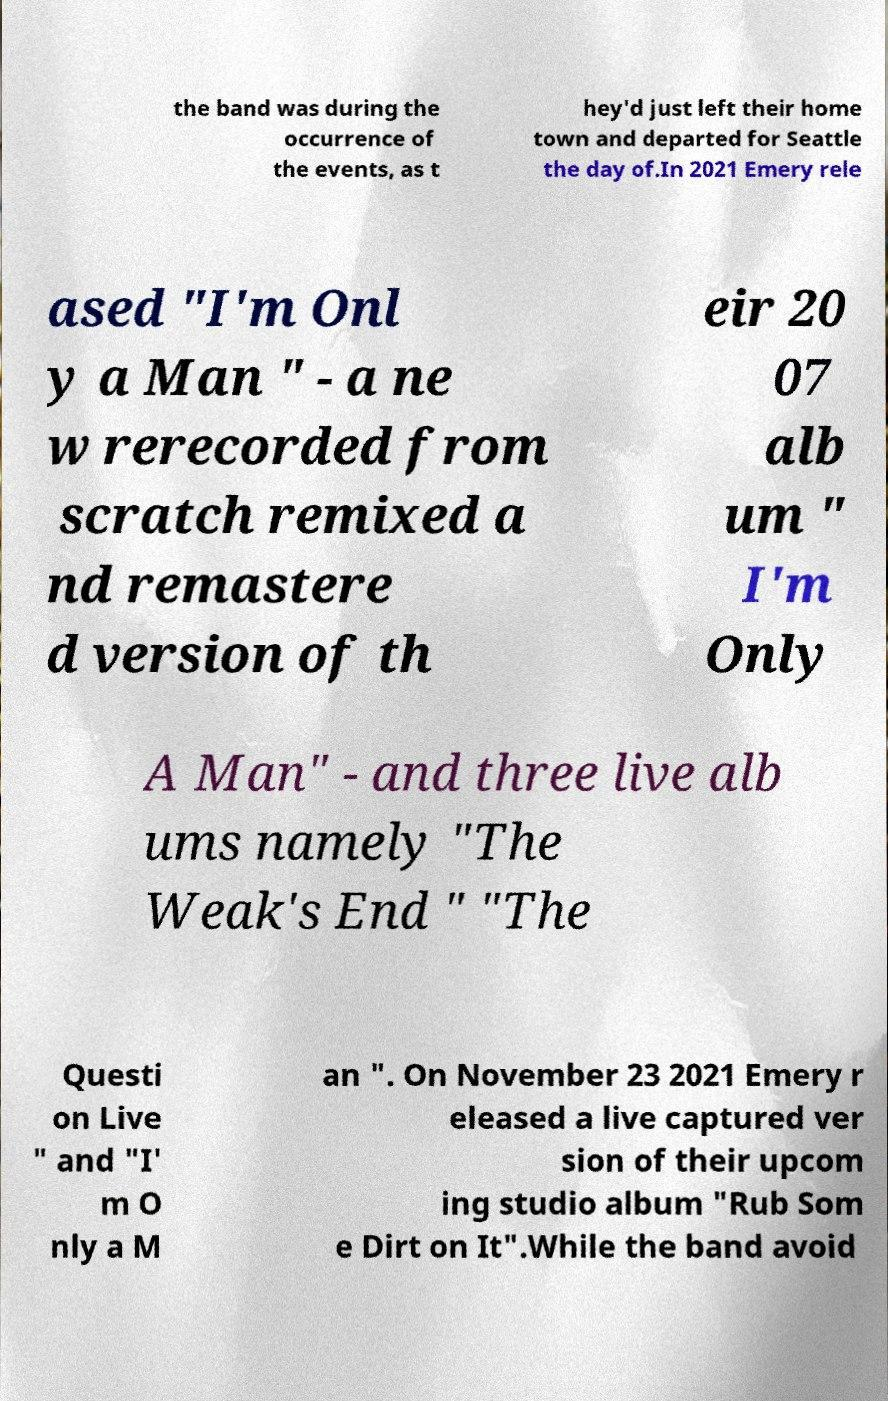Can you read and provide the text displayed in the image?This photo seems to have some interesting text. Can you extract and type it out for me? the band was during the occurrence of the events, as t hey'd just left their home town and departed for Seattle the day of.In 2021 Emery rele ased "I'm Onl y a Man " - a ne w rerecorded from scratch remixed a nd remastere d version of th eir 20 07 alb um " I'm Only A Man" - and three live alb ums namely "The Weak's End " "The Questi on Live " and "I' m O nly a M an ". On November 23 2021 Emery r eleased a live captured ver sion of their upcom ing studio album "Rub Som e Dirt on It".While the band avoid 